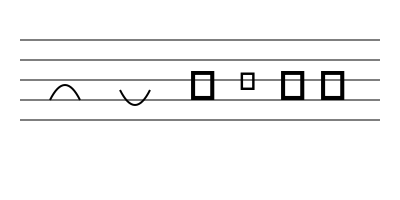As a local musician collaborating with a traveling artist, you encounter various musical notations. Identify the symbol that represents a key signature modification in this musical staff. Let's analyze the symbols in the image step-by-step:

1. The five horizontal lines represent a musical staff.

2. The curved lines connecting two notes are slurs, used to indicate that the notes should be played smoothly connected.

3. The symbol that looks like a stylized "G" is a treble clef, which indicates that the notes on the staff are in a higher range.

4. The symbol that looks like a lowercase "b" is a flat sign (♭). In music notation, it lowers the pitch of a note by a half step.

5. The two vertical lines with dots are bar lines. The one with two dots (𝄇) is a repeat sign indicating the end of a repeated section, while the one with dots on the left (𝄆) marks the beginning of a repeated section.

Among these symbols, only the flat sign (♭) is used to modify the key signature. It affects the pitch of notes throughout the piece unless cancelled by a natural sign or when the key signature changes.
Answer: Flat sign (♭) 